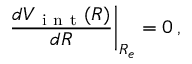Convert formula to latex. <formula><loc_0><loc_0><loc_500><loc_500>\frac { d V _ { i n t } ( R ) } { d R } \right | _ { R _ { e } } = 0 \, ,</formula> 